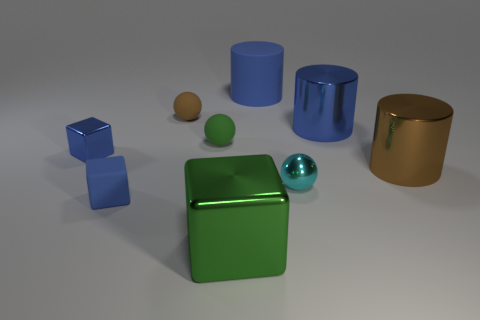Can you describe the objects that appear furthest to the left and furthest to the right in the image? The object furthest to the left is a pair of blue cubes, one slightly larger than the other, positioned close together. On the furthest right, there is a golden cylinder with a reflective surface and a slightly open lid.  What can you tell me about the different textures and materials visible in the scene? The objects in the image offer an array of textures and materials. The blue cubes and green cube appear to have a matte texture, suggesting a solid, non-reflective material like plastic or painted metal. The balls and the golden cylinder, along with the blue cylindrical object, have a glossy, reflective finish, indicating a smoother material like polished metal or glass. Matching their reflective surfaces, the illumination in the scene generates visible highlights and reflections on these objects. 